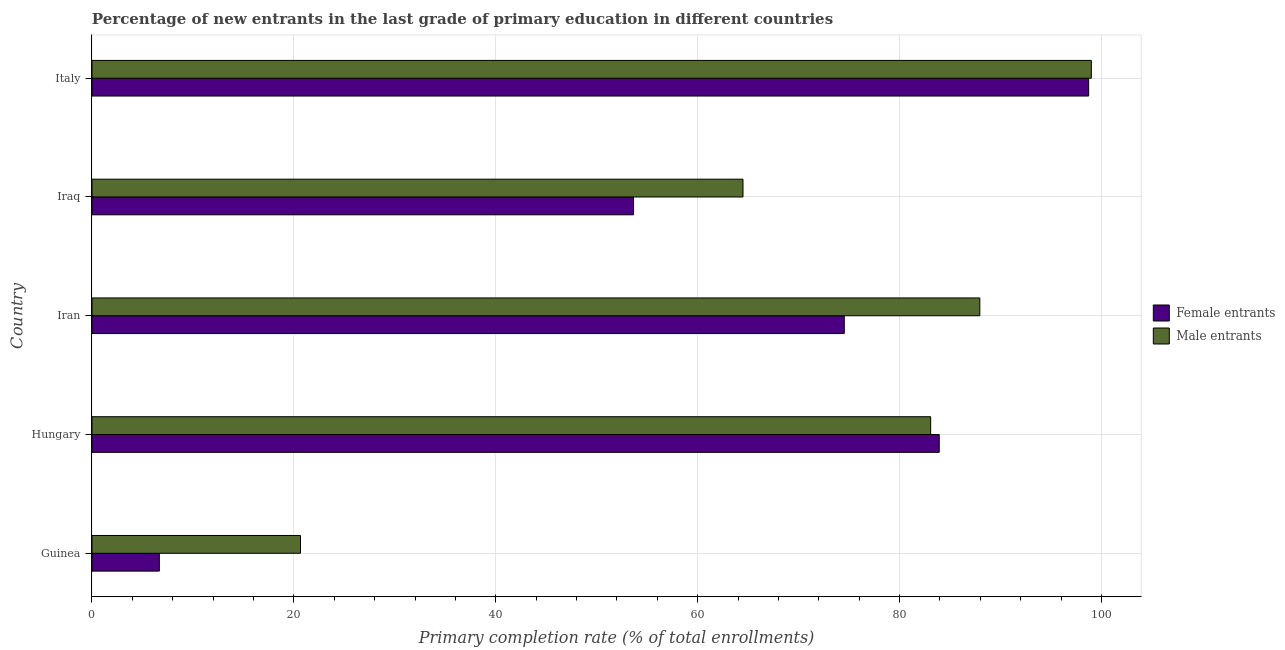How many different coloured bars are there?
Offer a terse response. 2. How many groups of bars are there?
Ensure brevity in your answer.  5. Are the number of bars per tick equal to the number of legend labels?
Offer a terse response. Yes. How many bars are there on the 5th tick from the top?
Keep it short and to the point. 2. How many bars are there on the 4th tick from the bottom?
Ensure brevity in your answer.  2. What is the label of the 1st group of bars from the top?
Provide a short and direct response. Italy. In how many cases, is the number of bars for a given country not equal to the number of legend labels?
Keep it short and to the point. 0. What is the primary completion rate of male entrants in Hungary?
Make the answer very short. 83.08. Across all countries, what is the maximum primary completion rate of female entrants?
Make the answer very short. 98.73. Across all countries, what is the minimum primary completion rate of male entrants?
Provide a succinct answer. 20.66. In which country was the primary completion rate of male entrants minimum?
Your response must be concise. Guinea. What is the total primary completion rate of male entrants in the graph?
Offer a very short reply. 355.17. What is the difference between the primary completion rate of female entrants in Guinea and that in Italy?
Provide a short and direct response. -92.06. What is the difference between the primary completion rate of female entrants in Hungary and the primary completion rate of male entrants in Guinea?
Your answer should be compact. 63.27. What is the average primary completion rate of male entrants per country?
Provide a short and direct response. 71.03. What is the difference between the primary completion rate of female entrants and primary completion rate of male entrants in Italy?
Give a very brief answer. -0.27. In how many countries, is the primary completion rate of female entrants greater than 68 %?
Provide a short and direct response. 3. What is the ratio of the primary completion rate of female entrants in Hungary to that in Iran?
Offer a very short reply. 1.13. What is the difference between the highest and the second highest primary completion rate of female entrants?
Provide a short and direct response. 14.8. What is the difference between the highest and the lowest primary completion rate of male entrants?
Provide a succinct answer. 78.34. In how many countries, is the primary completion rate of female entrants greater than the average primary completion rate of female entrants taken over all countries?
Offer a terse response. 3. Is the sum of the primary completion rate of male entrants in Guinea and Iraq greater than the maximum primary completion rate of female entrants across all countries?
Provide a succinct answer. No. What does the 1st bar from the top in Italy represents?
Make the answer very short. Male entrants. What does the 1st bar from the bottom in Hungary represents?
Give a very brief answer. Female entrants. How many bars are there?
Your response must be concise. 10. How many countries are there in the graph?
Keep it short and to the point. 5. What is the difference between two consecutive major ticks on the X-axis?
Provide a short and direct response. 20. Does the graph contain any zero values?
Give a very brief answer. No. Does the graph contain grids?
Provide a short and direct response. Yes. How many legend labels are there?
Keep it short and to the point. 2. How are the legend labels stacked?
Your answer should be very brief. Vertical. What is the title of the graph?
Ensure brevity in your answer.  Percentage of new entrants in the last grade of primary education in different countries. What is the label or title of the X-axis?
Make the answer very short. Primary completion rate (% of total enrollments). What is the Primary completion rate (% of total enrollments) in Female entrants in Guinea?
Offer a very short reply. 6.67. What is the Primary completion rate (% of total enrollments) of Male entrants in Guinea?
Provide a succinct answer. 20.66. What is the Primary completion rate (% of total enrollments) of Female entrants in Hungary?
Offer a terse response. 83.93. What is the Primary completion rate (% of total enrollments) of Male entrants in Hungary?
Ensure brevity in your answer.  83.08. What is the Primary completion rate (% of total enrollments) in Female entrants in Iran?
Provide a succinct answer. 74.52. What is the Primary completion rate (% of total enrollments) in Male entrants in Iran?
Your answer should be very brief. 87.95. What is the Primary completion rate (% of total enrollments) of Female entrants in Iraq?
Keep it short and to the point. 53.65. What is the Primary completion rate (% of total enrollments) in Male entrants in Iraq?
Make the answer very short. 64.49. What is the Primary completion rate (% of total enrollments) in Female entrants in Italy?
Give a very brief answer. 98.73. What is the Primary completion rate (% of total enrollments) of Male entrants in Italy?
Provide a short and direct response. 99. Across all countries, what is the maximum Primary completion rate (% of total enrollments) of Female entrants?
Keep it short and to the point. 98.73. Across all countries, what is the maximum Primary completion rate (% of total enrollments) in Male entrants?
Your answer should be compact. 99. Across all countries, what is the minimum Primary completion rate (% of total enrollments) in Female entrants?
Provide a short and direct response. 6.67. Across all countries, what is the minimum Primary completion rate (% of total enrollments) in Male entrants?
Ensure brevity in your answer.  20.66. What is the total Primary completion rate (% of total enrollments) in Female entrants in the graph?
Ensure brevity in your answer.  317.51. What is the total Primary completion rate (% of total enrollments) in Male entrants in the graph?
Your response must be concise. 355.17. What is the difference between the Primary completion rate (% of total enrollments) of Female entrants in Guinea and that in Hungary?
Your answer should be very brief. -77.26. What is the difference between the Primary completion rate (% of total enrollments) in Male entrants in Guinea and that in Hungary?
Offer a terse response. -62.42. What is the difference between the Primary completion rate (% of total enrollments) in Female entrants in Guinea and that in Iran?
Your response must be concise. -67.85. What is the difference between the Primary completion rate (% of total enrollments) of Male entrants in Guinea and that in Iran?
Make the answer very short. -67.29. What is the difference between the Primary completion rate (% of total enrollments) of Female entrants in Guinea and that in Iraq?
Ensure brevity in your answer.  -46.98. What is the difference between the Primary completion rate (% of total enrollments) of Male entrants in Guinea and that in Iraq?
Your answer should be compact. -43.84. What is the difference between the Primary completion rate (% of total enrollments) in Female entrants in Guinea and that in Italy?
Provide a short and direct response. -92.06. What is the difference between the Primary completion rate (% of total enrollments) of Male entrants in Guinea and that in Italy?
Provide a succinct answer. -78.34. What is the difference between the Primary completion rate (% of total enrollments) in Female entrants in Hungary and that in Iran?
Your answer should be compact. 9.41. What is the difference between the Primary completion rate (% of total enrollments) of Male entrants in Hungary and that in Iran?
Your answer should be compact. -4.87. What is the difference between the Primary completion rate (% of total enrollments) of Female entrants in Hungary and that in Iraq?
Your response must be concise. 30.28. What is the difference between the Primary completion rate (% of total enrollments) of Male entrants in Hungary and that in Iraq?
Provide a short and direct response. 18.59. What is the difference between the Primary completion rate (% of total enrollments) of Female entrants in Hungary and that in Italy?
Offer a terse response. -14.8. What is the difference between the Primary completion rate (% of total enrollments) of Male entrants in Hungary and that in Italy?
Make the answer very short. -15.92. What is the difference between the Primary completion rate (% of total enrollments) in Female entrants in Iran and that in Iraq?
Your answer should be compact. 20.87. What is the difference between the Primary completion rate (% of total enrollments) in Male entrants in Iran and that in Iraq?
Your response must be concise. 23.46. What is the difference between the Primary completion rate (% of total enrollments) in Female entrants in Iran and that in Italy?
Ensure brevity in your answer.  -24.21. What is the difference between the Primary completion rate (% of total enrollments) of Male entrants in Iran and that in Italy?
Offer a very short reply. -11.05. What is the difference between the Primary completion rate (% of total enrollments) of Female entrants in Iraq and that in Italy?
Ensure brevity in your answer.  -45.08. What is the difference between the Primary completion rate (% of total enrollments) of Male entrants in Iraq and that in Italy?
Offer a very short reply. -34.51. What is the difference between the Primary completion rate (% of total enrollments) of Female entrants in Guinea and the Primary completion rate (% of total enrollments) of Male entrants in Hungary?
Your response must be concise. -76.41. What is the difference between the Primary completion rate (% of total enrollments) of Female entrants in Guinea and the Primary completion rate (% of total enrollments) of Male entrants in Iran?
Offer a terse response. -81.28. What is the difference between the Primary completion rate (% of total enrollments) of Female entrants in Guinea and the Primary completion rate (% of total enrollments) of Male entrants in Iraq?
Your answer should be compact. -57.82. What is the difference between the Primary completion rate (% of total enrollments) of Female entrants in Guinea and the Primary completion rate (% of total enrollments) of Male entrants in Italy?
Your answer should be compact. -92.32. What is the difference between the Primary completion rate (% of total enrollments) in Female entrants in Hungary and the Primary completion rate (% of total enrollments) in Male entrants in Iran?
Offer a terse response. -4.02. What is the difference between the Primary completion rate (% of total enrollments) of Female entrants in Hungary and the Primary completion rate (% of total enrollments) of Male entrants in Iraq?
Your response must be concise. 19.44. What is the difference between the Primary completion rate (% of total enrollments) of Female entrants in Hungary and the Primary completion rate (% of total enrollments) of Male entrants in Italy?
Your response must be concise. -15.07. What is the difference between the Primary completion rate (% of total enrollments) in Female entrants in Iran and the Primary completion rate (% of total enrollments) in Male entrants in Iraq?
Provide a succinct answer. 10.03. What is the difference between the Primary completion rate (% of total enrollments) in Female entrants in Iran and the Primary completion rate (% of total enrollments) in Male entrants in Italy?
Offer a terse response. -24.47. What is the difference between the Primary completion rate (% of total enrollments) of Female entrants in Iraq and the Primary completion rate (% of total enrollments) of Male entrants in Italy?
Offer a terse response. -45.35. What is the average Primary completion rate (% of total enrollments) in Female entrants per country?
Provide a short and direct response. 63.5. What is the average Primary completion rate (% of total enrollments) in Male entrants per country?
Provide a succinct answer. 71.03. What is the difference between the Primary completion rate (% of total enrollments) of Female entrants and Primary completion rate (% of total enrollments) of Male entrants in Guinea?
Your response must be concise. -13.98. What is the difference between the Primary completion rate (% of total enrollments) in Female entrants and Primary completion rate (% of total enrollments) in Male entrants in Hungary?
Ensure brevity in your answer.  0.85. What is the difference between the Primary completion rate (% of total enrollments) of Female entrants and Primary completion rate (% of total enrollments) of Male entrants in Iran?
Offer a terse response. -13.43. What is the difference between the Primary completion rate (% of total enrollments) in Female entrants and Primary completion rate (% of total enrollments) in Male entrants in Iraq?
Keep it short and to the point. -10.84. What is the difference between the Primary completion rate (% of total enrollments) of Female entrants and Primary completion rate (% of total enrollments) of Male entrants in Italy?
Offer a very short reply. -0.27. What is the ratio of the Primary completion rate (% of total enrollments) in Female entrants in Guinea to that in Hungary?
Offer a terse response. 0.08. What is the ratio of the Primary completion rate (% of total enrollments) of Male entrants in Guinea to that in Hungary?
Ensure brevity in your answer.  0.25. What is the ratio of the Primary completion rate (% of total enrollments) in Female entrants in Guinea to that in Iran?
Your answer should be compact. 0.09. What is the ratio of the Primary completion rate (% of total enrollments) in Male entrants in Guinea to that in Iran?
Offer a very short reply. 0.23. What is the ratio of the Primary completion rate (% of total enrollments) of Female entrants in Guinea to that in Iraq?
Provide a short and direct response. 0.12. What is the ratio of the Primary completion rate (% of total enrollments) of Male entrants in Guinea to that in Iraq?
Give a very brief answer. 0.32. What is the ratio of the Primary completion rate (% of total enrollments) of Female entrants in Guinea to that in Italy?
Ensure brevity in your answer.  0.07. What is the ratio of the Primary completion rate (% of total enrollments) of Male entrants in Guinea to that in Italy?
Provide a short and direct response. 0.21. What is the ratio of the Primary completion rate (% of total enrollments) of Female entrants in Hungary to that in Iran?
Provide a short and direct response. 1.13. What is the ratio of the Primary completion rate (% of total enrollments) in Male entrants in Hungary to that in Iran?
Your answer should be compact. 0.94. What is the ratio of the Primary completion rate (% of total enrollments) of Female entrants in Hungary to that in Iraq?
Provide a succinct answer. 1.56. What is the ratio of the Primary completion rate (% of total enrollments) of Male entrants in Hungary to that in Iraq?
Your response must be concise. 1.29. What is the ratio of the Primary completion rate (% of total enrollments) of Female entrants in Hungary to that in Italy?
Give a very brief answer. 0.85. What is the ratio of the Primary completion rate (% of total enrollments) in Male entrants in Hungary to that in Italy?
Provide a succinct answer. 0.84. What is the ratio of the Primary completion rate (% of total enrollments) in Female entrants in Iran to that in Iraq?
Offer a very short reply. 1.39. What is the ratio of the Primary completion rate (% of total enrollments) in Male entrants in Iran to that in Iraq?
Provide a short and direct response. 1.36. What is the ratio of the Primary completion rate (% of total enrollments) in Female entrants in Iran to that in Italy?
Keep it short and to the point. 0.75. What is the ratio of the Primary completion rate (% of total enrollments) in Male entrants in Iran to that in Italy?
Your answer should be very brief. 0.89. What is the ratio of the Primary completion rate (% of total enrollments) of Female entrants in Iraq to that in Italy?
Your answer should be compact. 0.54. What is the ratio of the Primary completion rate (% of total enrollments) of Male entrants in Iraq to that in Italy?
Make the answer very short. 0.65. What is the difference between the highest and the second highest Primary completion rate (% of total enrollments) of Female entrants?
Make the answer very short. 14.8. What is the difference between the highest and the second highest Primary completion rate (% of total enrollments) of Male entrants?
Your answer should be very brief. 11.05. What is the difference between the highest and the lowest Primary completion rate (% of total enrollments) of Female entrants?
Provide a succinct answer. 92.06. What is the difference between the highest and the lowest Primary completion rate (% of total enrollments) of Male entrants?
Your answer should be compact. 78.34. 